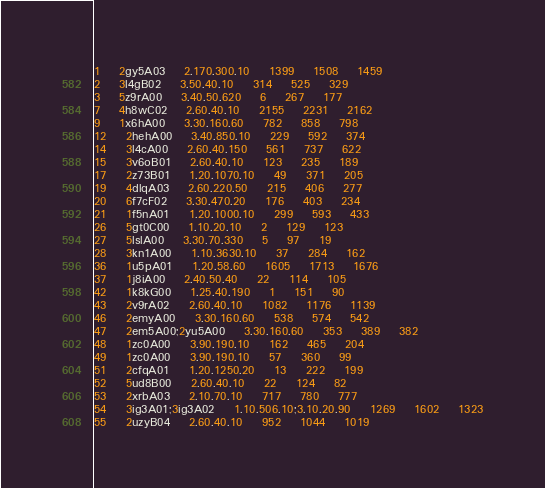<code> <loc_0><loc_0><loc_500><loc_500><_SQL_>1	2gy5A03	2.170.300.10	1399	1508	1459
2	3l4gB02	3.50.40.10	314	525	329
3	5z9rA00	3.40.50.620	6	267	177
7	4h8wC02	2.60.40.10	2155	2231	2162
9	1x6hA00	3.30.160.60	782	858	798
12	2hehA00	3.40.850.10	229	592	374
14	3l4cA00	2.60.40.150	561	737	622
15	3v6oB01	2.60.40.10	123	235	189
17	2z73B01	1.20.1070.10	49	371	205
19	4dlqA03	2.60.220.50	215	406	277
20	6f7cF02	3.30.470.20	176	403	234
21	1f5nA01	1.20.1000.10	299	593	433
26	5gt0C00	1.10.20.10	2	129	123
27	5lslA00	3.30.70.330	5	97	19
28	3kn1A00	1.10.3630.10	37	284	162
36	1u5pA01	1.20.58.60	1605	1713	1676
37	1j8iA00	2.40.50.40	22	114	105
42	1k8kG00	1.25.40.190	1	151	90
43	2v9rA02	2.60.40.10	1082	1176	1139
46	2emyA00	3.30.160.60	538	574	542
47	2em5A00;2yu5A00	3.30.160.60	353	389	382
48	1zc0A00	3.90.190.10	162	465	204
49	1zc0A00	3.90.190.10	57	360	99
51	2cfqA01	1.20.1250.20	13	222	199
52	5ud8B00	2.60.40.10	22	124	82
53	2xrbA03	2.10.70.10	717	780	777
54	3ig3A01;3ig3A02	1.10.506.10;3.10.20.90	1269	1602	1323
55	2uzyB04	2.60.40.10	952	1044	1019</code> 